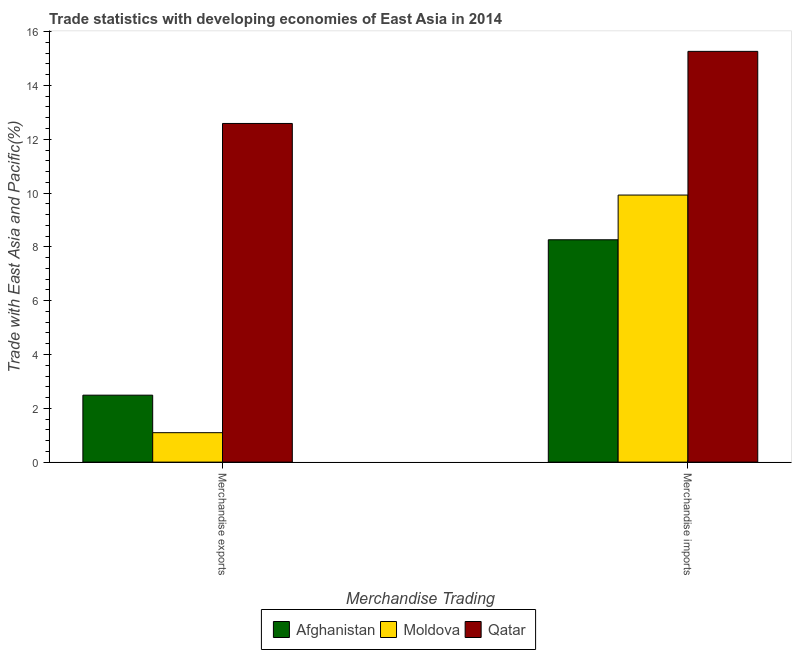Are the number of bars per tick equal to the number of legend labels?
Offer a very short reply. Yes. Are the number of bars on each tick of the X-axis equal?
Keep it short and to the point. Yes. How many bars are there on the 1st tick from the right?
Keep it short and to the point. 3. What is the merchandise exports in Afghanistan?
Offer a terse response. 2.49. Across all countries, what is the maximum merchandise exports?
Your response must be concise. 12.59. Across all countries, what is the minimum merchandise imports?
Offer a very short reply. 8.26. In which country was the merchandise imports maximum?
Your answer should be compact. Qatar. In which country was the merchandise exports minimum?
Give a very brief answer. Moldova. What is the total merchandise exports in the graph?
Provide a short and direct response. 16.17. What is the difference between the merchandise exports in Moldova and that in Qatar?
Provide a short and direct response. -11.49. What is the difference between the merchandise exports in Qatar and the merchandise imports in Afghanistan?
Offer a very short reply. 4.32. What is the average merchandise exports per country?
Make the answer very short. 5.39. What is the difference between the merchandise exports and merchandise imports in Afghanistan?
Ensure brevity in your answer.  -5.78. What is the ratio of the merchandise exports in Qatar to that in Moldova?
Your answer should be very brief. 11.5. What does the 1st bar from the left in Merchandise exports represents?
Offer a terse response. Afghanistan. What does the 2nd bar from the right in Merchandise exports represents?
Provide a short and direct response. Moldova. How many bars are there?
Your answer should be compact. 6. How many countries are there in the graph?
Your response must be concise. 3. What is the difference between two consecutive major ticks on the Y-axis?
Make the answer very short. 2. Are the values on the major ticks of Y-axis written in scientific E-notation?
Your answer should be compact. No. Does the graph contain grids?
Keep it short and to the point. No. What is the title of the graph?
Provide a short and direct response. Trade statistics with developing economies of East Asia in 2014. Does "Bhutan" appear as one of the legend labels in the graph?
Your answer should be compact. No. What is the label or title of the X-axis?
Your answer should be very brief. Merchandise Trading. What is the label or title of the Y-axis?
Provide a succinct answer. Trade with East Asia and Pacific(%). What is the Trade with East Asia and Pacific(%) in Afghanistan in Merchandise exports?
Provide a short and direct response. 2.49. What is the Trade with East Asia and Pacific(%) in Moldova in Merchandise exports?
Keep it short and to the point. 1.09. What is the Trade with East Asia and Pacific(%) in Qatar in Merchandise exports?
Make the answer very short. 12.59. What is the Trade with East Asia and Pacific(%) of Afghanistan in Merchandise imports?
Your answer should be very brief. 8.26. What is the Trade with East Asia and Pacific(%) of Moldova in Merchandise imports?
Your response must be concise. 9.93. What is the Trade with East Asia and Pacific(%) in Qatar in Merchandise imports?
Offer a terse response. 15.27. Across all Merchandise Trading, what is the maximum Trade with East Asia and Pacific(%) of Afghanistan?
Your answer should be very brief. 8.26. Across all Merchandise Trading, what is the maximum Trade with East Asia and Pacific(%) of Moldova?
Make the answer very short. 9.93. Across all Merchandise Trading, what is the maximum Trade with East Asia and Pacific(%) in Qatar?
Offer a terse response. 15.27. Across all Merchandise Trading, what is the minimum Trade with East Asia and Pacific(%) in Afghanistan?
Give a very brief answer. 2.49. Across all Merchandise Trading, what is the minimum Trade with East Asia and Pacific(%) of Moldova?
Make the answer very short. 1.09. Across all Merchandise Trading, what is the minimum Trade with East Asia and Pacific(%) in Qatar?
Keep it short and to the point. 12.59. What is the total Trade with East Asia and Pacific(%) of Afghanistan in the graph?
Make the answer very short. 10.75. What is the total Trade with East Asia and Pacific(%) in Moldova in the graph?
Offer a very short reply. 11.02. What is the total Trade with East Asia and Pacific(%) in Qatar in the graph?
Provide a short and direct response. 27.86. What is the difference between the Trade with East Asia and Pacific(%) of Afghanistan in Merchandise exports and that in Merchandise imports?
Make the answer very short. -5.78. What is the difference between the Trade with East Asia and Pacific(%) of Moldova in Merchandise exports and that in Merchandise imports?
Keep it short and to the point. -8.83. What is the difference between the Trade with East Asia and Pacific(%) of Qatar in Merchandise exports and that in Merchandise imports?
Your response must be concise. -2.68. What is the difference between the Trade with East Asia and Pacific(%) of Afghanistan in Merchandise exports and the Trade with East Asia and Pacific(%) of Moldova in Merchandise imports?
Offer a very short reply. -7.44. What is the difference between the Trade with East Asia and Pacific(%) of Afghanistan in Merchandise exports and the Trade with East Asia and Pacific(%) of Qatar in Merchandise imports?
Provide a succinct answer. -12.78. What is the difference between the Trade with East Asia and Pacific(%) of Moldova in Merchandise exports and the Trade with East Asia and Pacific(%) of Qatar in Merchandise imports?
Your answer should be very brief. -14.17. What is the average Trade with East Asia and Pacific(%) in Afghanistan per Merchandise Trading?
Keep it short and to the point. 5.38. What is the average Trade with East Asia and Pacific(%) of Moldova per Merchandise Trading?
Provide a succinct answer. 5.51. What is the average Trade with East Asia and Pacific(%) in Qatar per Merchandise Trading?
Ensure brevity in your answer.  13.93. What is the difference between the Trade with East Asia and Pacific(%) in Afghanistan and Trade with East Asia and Pacific(%) in Moldova in Merchandise exports?
Ensure brevity in your answer.  1.39. What is the difference between the Trade with East Asia and Pacific(%) of Afghanistan and Trade with East Asia and Pacific(%) of Qatar in Merchandise exports?
Offer a terse response. -10.1. What is the difference between the Trade with East Asia and Pacific(%) of Moldova and Trade with East Asia and Pacific(%) of Qatar in Merchandise exports?
Offer a very short reply. -11.49. What is the difference between the Trade with East Asia and Pacific(%) of Afghanistan and Trade with East Asia and Pacific(%) of Moldova in Merchandise imports?
Make the answer very short. -1.66. What is the difference between the Trade with East Asia and Pacific(%) in Afghanistan and Trade with East Asia and Pacific(%) in Qatar in Merchandise imports?
Give a very brief answer. -7. What is the difference between the Trade with East Asia and Pacific(%) in Moldova and Trade with East Asia and Pacific(%) in Qatar in Merchandise imports?
Keep it short and to the point. -5.34. What is the ratio of the Trade with East Asia and Pacific(%) in Afghanistan in Merchandise exports to that in Merchandise imports?
Give a very brief answer. 0.3. What is the ratio of the Trade with East Asia and Pacific(%) in Moldova in Merchandise exports to that in Merchandise imports?
Your answer should be very brief. 0.11. What is the ratio of the Trade with East Asia and Pacific(%) in Qatar in Merchandise exports to that in Merchandise imports?
Make the answer very short. 0.82. What is the difference between the highest and the second highest Trade with East Asia and Pacific(%) of Afghanistan?
Ensure brevity in your answer.  5.78. What is the difference between the highest and the second highest Trade with East Asia and Pacific(%) in Moldova?
Provide a short and direct response. 8.83. What is the difference between the highest and the second highest Trade with East Asia and Pacific(%) of Qatar?
Make the answer very short. 2.68. What is the difference between the highest and the lowest Trade with East Asia and Pacific(%) in Afghanistan?
Give a very brief answer. 5.78. What is the difference between the highest and the lowest Trade with East Asia and Pacific(%) in Moldova?
Keep it short and to the point. 8.83. What is the difference between the highest and the lowest Trade with East Asia and Pacific(%) of Qatar?
Your response must be concise. 2.68. 